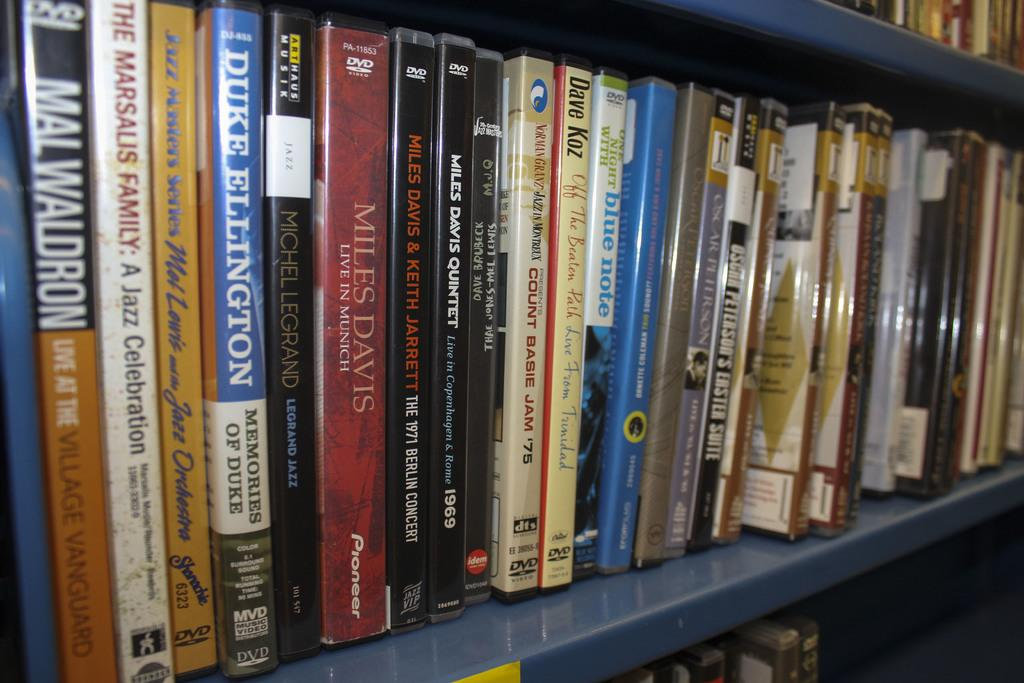<image>
Share a concise interpretation of the image provided. A large amount of books on shelves and one of them is about Duke Ellington. 